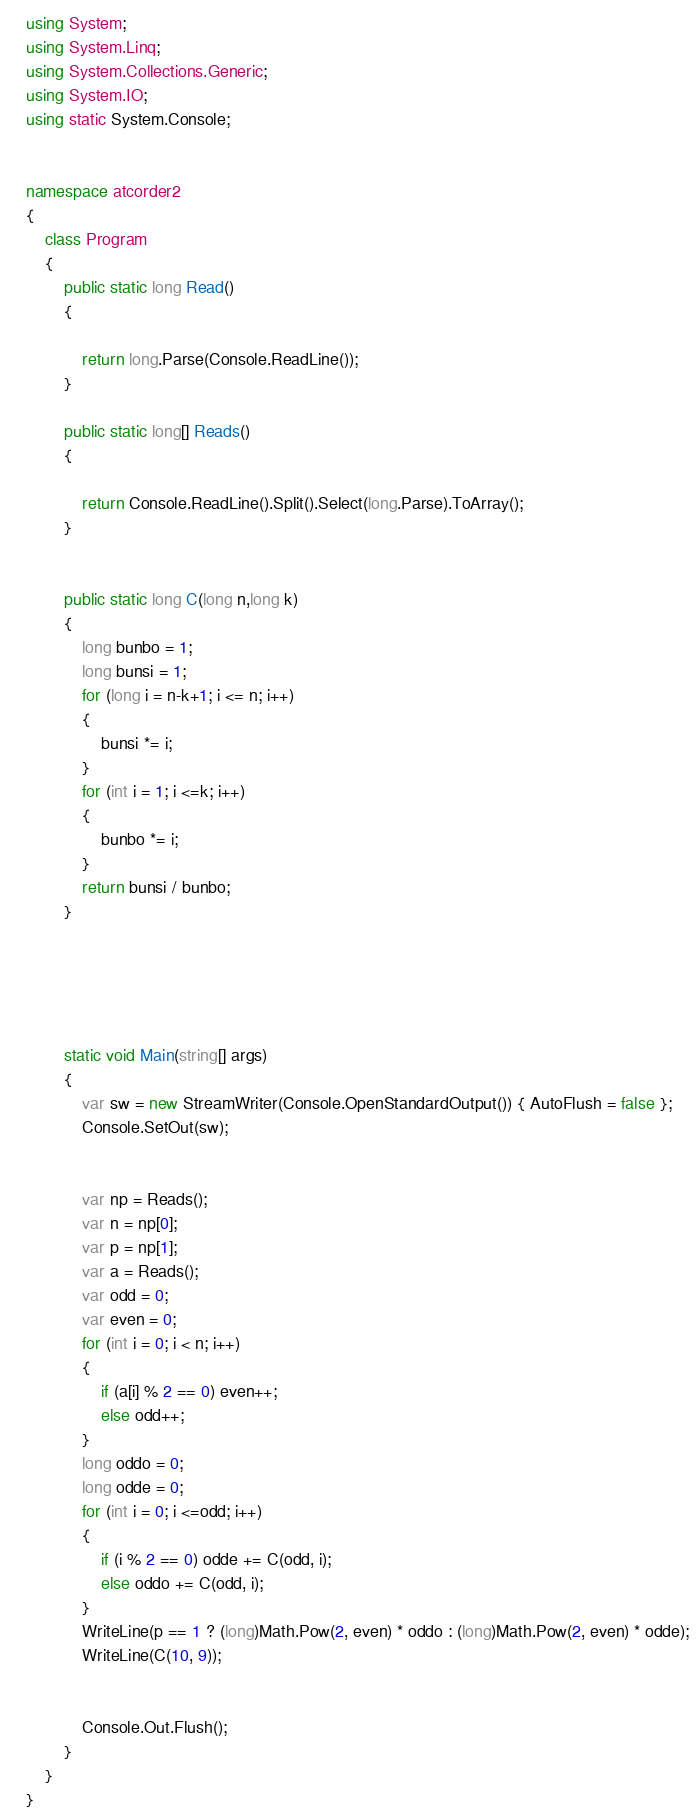Convert code to text. <code><loc_0><loc_0><loc_500><loc_500><_C#_>using System;
using System.Linq;
using System.Collections.Generic;
using System.IO;
using static System.Console;


namespace atcorder2
{
    class Program
    {
        public static long Read()
        {

            return long.Parse(Console.ReadLine());
        }

        public static long[] Reads()
        {

            return Console.ReadLine().Split().Select(long.Parse).ToArray();
        }

       
        public static long C(long n,long k)
        {
            long bunbo = 1;
            long bunsi = 1;
            for (long i = n-k+1; i <= n; i++)
            {
                bunsi *= i;
            }
            for (int i = 1; i <=k; i++)
            {
                bunbo *= i;
            }
            return bunsi / bunbo;
        }

        



        static void Main(string[] args)
        {
            var sw = new StreamWriter(Console.OpenStandardOutput()) { AutoFlush = false };
            Console.SetOut(sw);


            var np = Reads();
            var n = np[0];
            var p = np[1];
            var a = Reads();
            var odd = 0;
            var even = 0;
            for (int i = 0; i < n; i++)
            {
                if (a[i] % 2 == 0) even++;
                else odd++;
            }
            long oddo = 0;
            long odde = 0;
            for (int i = 0; i <=odd; i++)
            {
                if (i % 2 == 0) odde += C(odd, i);
                else oddo += C(odd, i);
            }
            WriteLine(p == 1 ? (long)Math.Pow(2, even) * oddo : (long)Math.Pow(2, even) * odde);
            WriteLine(C(10, 9));


            Console.Out.Flush();
        }
    }
}


</code> 